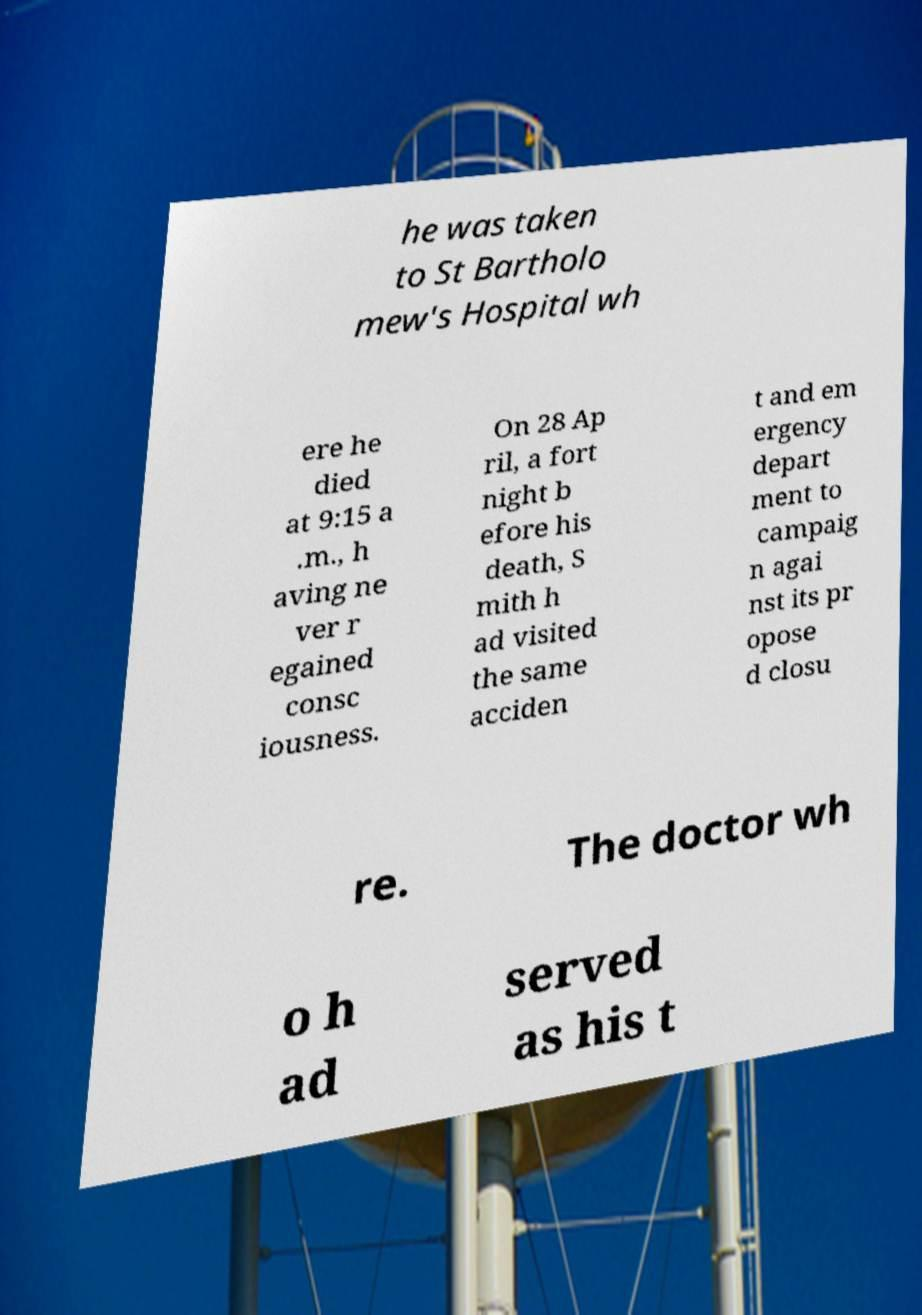What messages or text are displayed in this image? I need them in a readable, typed format. he was taken to St Bartholo mew's Hospital wh ere he died at 9:15 a .m., h aving ne ver r egained consc iousness. On 28 Ap ril, a fort night b efore his death, S mith h ad visited the same acciden t and em ergency depart ment to campaig n agai nst its pr opose d closu re. The doctor wh o h ad served as his t 